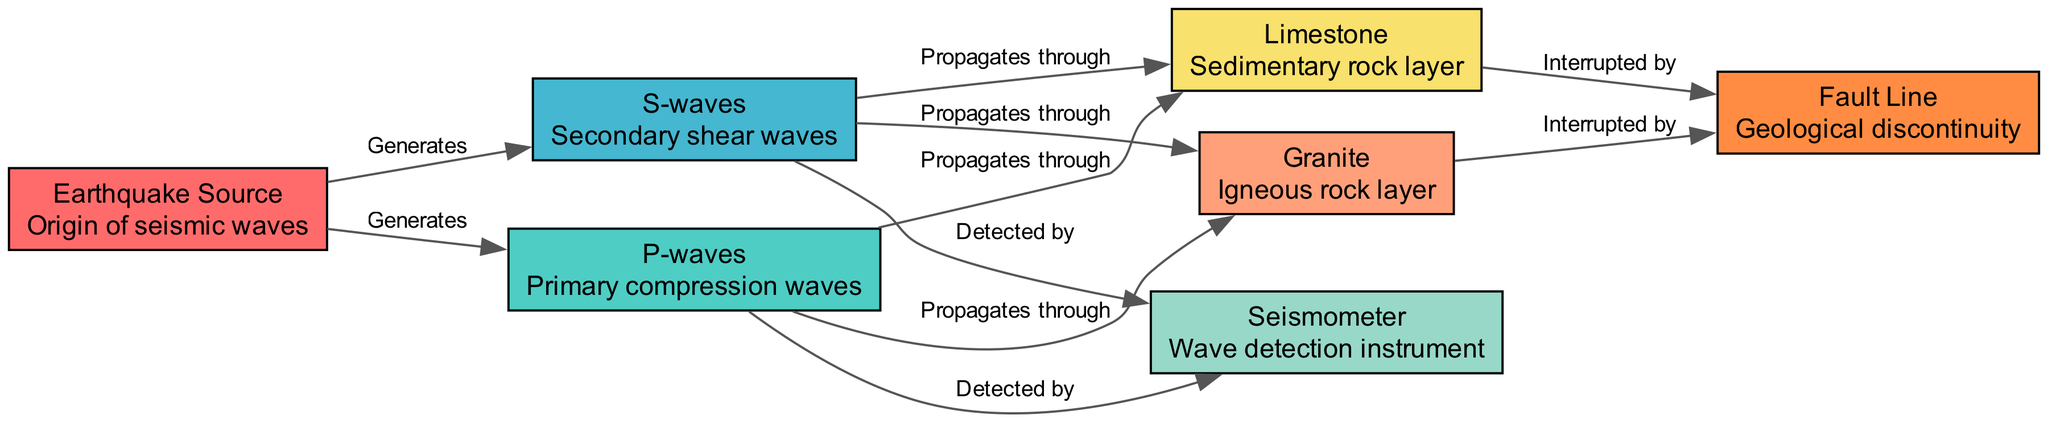What is the origin of seismic waves? The diagram indicates the "Earthquake Source" as the starting point for seismic waves, where they are generated.
Answer: Earthquake Source How many types of seismic waves are present in the diagram? The diagram shows two types of seismic waves: P-waves and S-waves, clearly labeled in the nodes.
Answer: 2 What geological layer do P-waves propagate through? P-waves propagate through both Granite and Limestone as indicated by the edges connecting the P-waves node to these two rock types.
Answer: Granite and Limestone What does the Fault Line represent in the diagram? The Fault Line is a geological discontinuity that interrupts the propagation of seismic waves, as shown by the connecting edges from both Granite and Limestone.
Answer: Geological discontinuity Which instrument detects both P-waves and S-waves? The Seismometer is identified in the diagram as the instrument that detects both types of seismic waves, as indicated by the edges linking it to the P-waves and S-waves nodes.
Answer: Seismometer What type of waves propagate through Granite? Both P-waves and S-waves propagate through Granite, as evidenced by the edges leading from these wave types to the Granite node.
Answer: P-waves and S-waves What interrupts the seismic waves according to the diagram? Both P-waves and S-waves are shown to be interrupted by the Fault Line, which is a key geological feature represented in the diagram.
Answer: Fault Line From which source do the seismic waves originate? The waves originate from the Earthquake Source, as depicted at the start of the propagation path in the diagram.
Answer: Earthquake Source What is the primary type of wave generated by the Earthquake Source? The primary type of wave generated by the Earthquake Source is the P-wave, as indicated by the direct connection in the diagram.
Answer: P-wave 